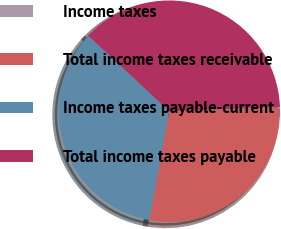Convert chart. <chart><loc_0><loc_0><loc_500><loc_500><pie_chart><fcel>Income taxes<fcel>Total income taxes receivable<fcel>Income taxes payable-current<fcel>Total income taxes payable<nl><fcel>0.17%<fcel>28.3%<fcel>34.06%<fcel>37.47%<nl></chart> 